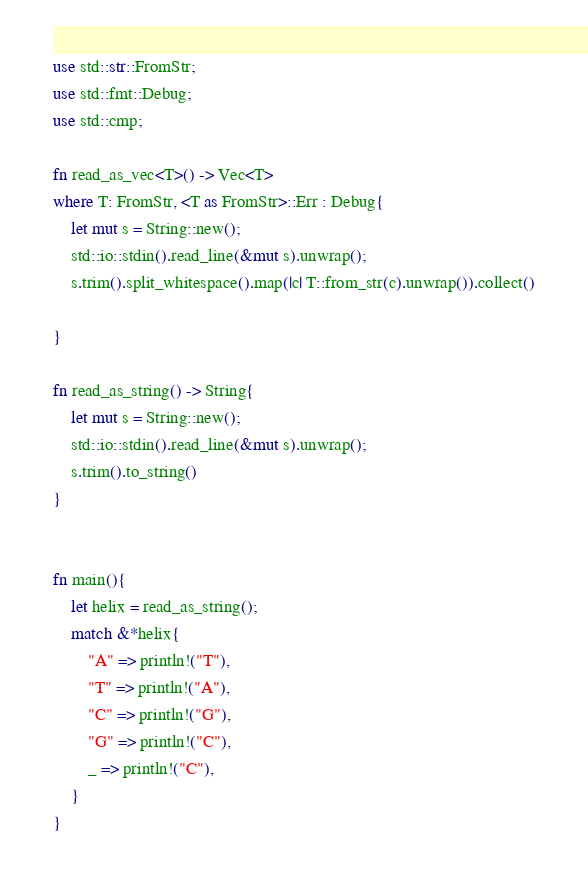<code> <loc_0><loc_0><loc_500><loc_500><_Rust_>use std::str::FromStr;
use std::fmt::Debug;
use std::cmp;

fn read_as_vec<T>() -> Vec<T>
where T: FromStr, <T as FromStr>::Err : Debug{
    let mut s = String::new();
    std::io::stdin().read_line(&mut s).unwrap();
    s.trim().split_whitespace().map(|c| T::from_str(c).unwrap()).collect()

}

fn read_as_string() -> String{
    let mut s = String::new();
    std::io::stdin().read_line(&mut s).unwrap();
    s.trim().to_string()
}


fn main(){
    let helix = read_as_string();
    match &*helix{
        "A" => println!("T"),
        "T" => println!("A"),
        "C" => println!("G"),
        "G" => println!("C"),
        _ => println!("C"),
    }
}
</code> 